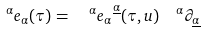<formula> <loc_0><loc_0><loc_500><loc_500>\quad ^ { \alpha } e _ { \alpha } ( \tau ) = \ \ ^ { \alpha } e _ { \alpha } ^ { \ \underline { \alpha } } ( \tau , u ) \ \ ^ { \alpha } \partial _ { \underline { \alpha } }</formula> 